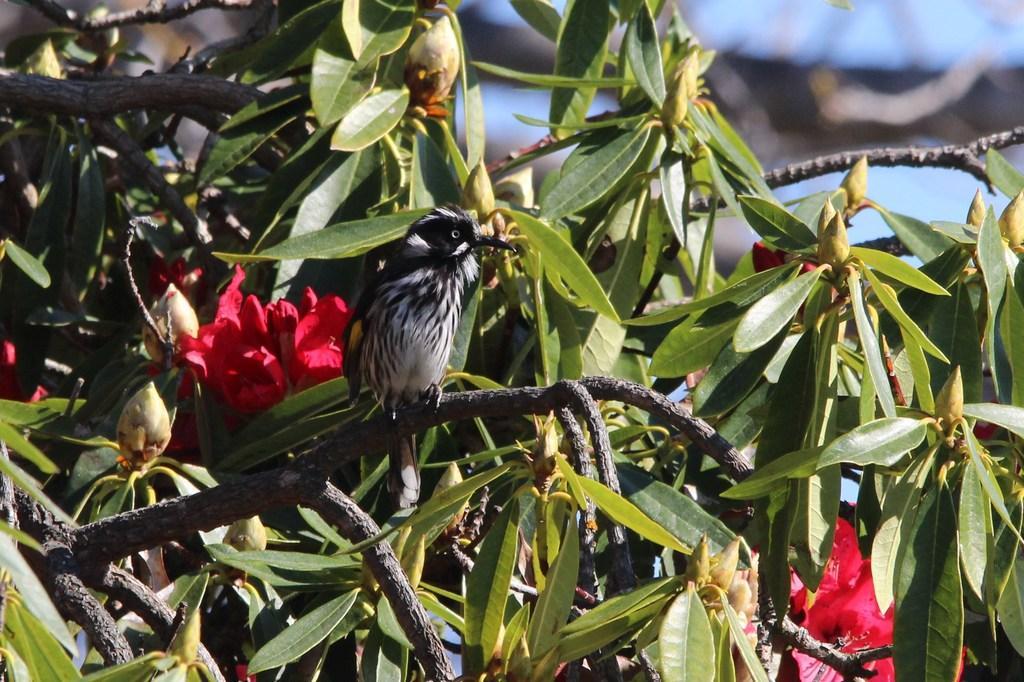Describe this image in one or two sentences. In this picture there is a sparrow who is standing on the tree branch. On that tree i can see the red flowers and buds. At the bottom I can see many leaves. In the top right corner there is a sky. 